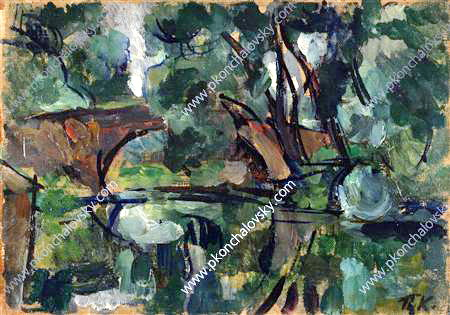Describe the mood and atmosphere conveyed in this artwork. The mood of this artwork is serene and contemplative. The harmonious blend of blues and greens evokes a sense of calm and tranquility, while the loose, energetic brushstrokes infuse the scene with a quiet vitality. The peaceful pond at the center reflects the sky and surrounding trees, creating a mirror-like effect that enhances the feeling of stillness and reflection. This tranquil scene invites viewers to pause and immerse themselves in the natural beauty, experiencing a moment of introspection and peace. If you could step into this painting, what sounds would you hear? Stepping into this painting, you would be enveloped by the gentle sounds of nature. The soft rustling of leaves as the wind moves through the trees would provide a soothing backdrop. You might hear the quiet lapping of water against the pond's edge, perhaps accompanied by the distant sounds of birds chirping and insects buzzing. The ambiance would be peaceful, with the occasional creak of branches or the plop of a frog hopping into the water. This natural symphony would underscore the serenity of the scene, making it a perfect escape from the hustle and bustle of everyday life. What do you think inspired the artist to create this scene? The artist was likely inspired by the beauty and tranquility of nature. The serene pond, surrounded by lush greenery, may have been a favored retreat, a place where the artist could find peace and focus. The vibrant use of color and dynamic brushwork suggest that the artist was deeply moved by the ever-changing light and natural forms. This painting captures not just the physical appearance of the landscape, but also the artist's emotional response to it, conveying a sense of awe and gratitude for the simple, yet profound beauty of the natural world. Imagine this pond is magical. What kind of magical properties might it have? Imagine this pond is imbued with enchanting properties. Its waters have the ability to reveal one's true desires when gazed into deeply, reflecting not just the physical surroundings but also the innermost thoughts and dreams of the viewer. Lush with ancient, whispering trees that communicate stories of times long past, the pond serves as a mystical portal—glimmering under the moonlight, it opens pathways to other realms where one can converse with ethereal beings or explore mythical landscapes. The air around it is filled with an ever-present, faint melody that soothes the soul, and the flora and fauna thrive with unusual vibrancy, nurtured by the pond's magical essence. This captivating place might even have the power to heal ailments or grant visions of futures untold to those who come seeking truth and wisdom.  Describe the setting as if it were part of a story. In the heart of the ancient forest, where time seemed to stand still, lay a hidden pond surrounded by gnarled, whispering trees. The water, clear as crystal and deep as a midnight sky, mirrored the vibrant hues of the world above and around it. This wasn't just any pond; it was the legendary Mirror of Fate, a place where seekers came from distant lands in hope of glimpsing their destiny. The air was thick with the scent of moss and blooming wildflowers, and the sounds of nature harmonized into a soothing, mystical melody. This setting served as the backdrop for countless tales of adventure, where heroes and heroines discovered their true calling within its reflective depths. The energy of this place was palpable; each breeze carried ancient secrets and the promise of new beginnings. 